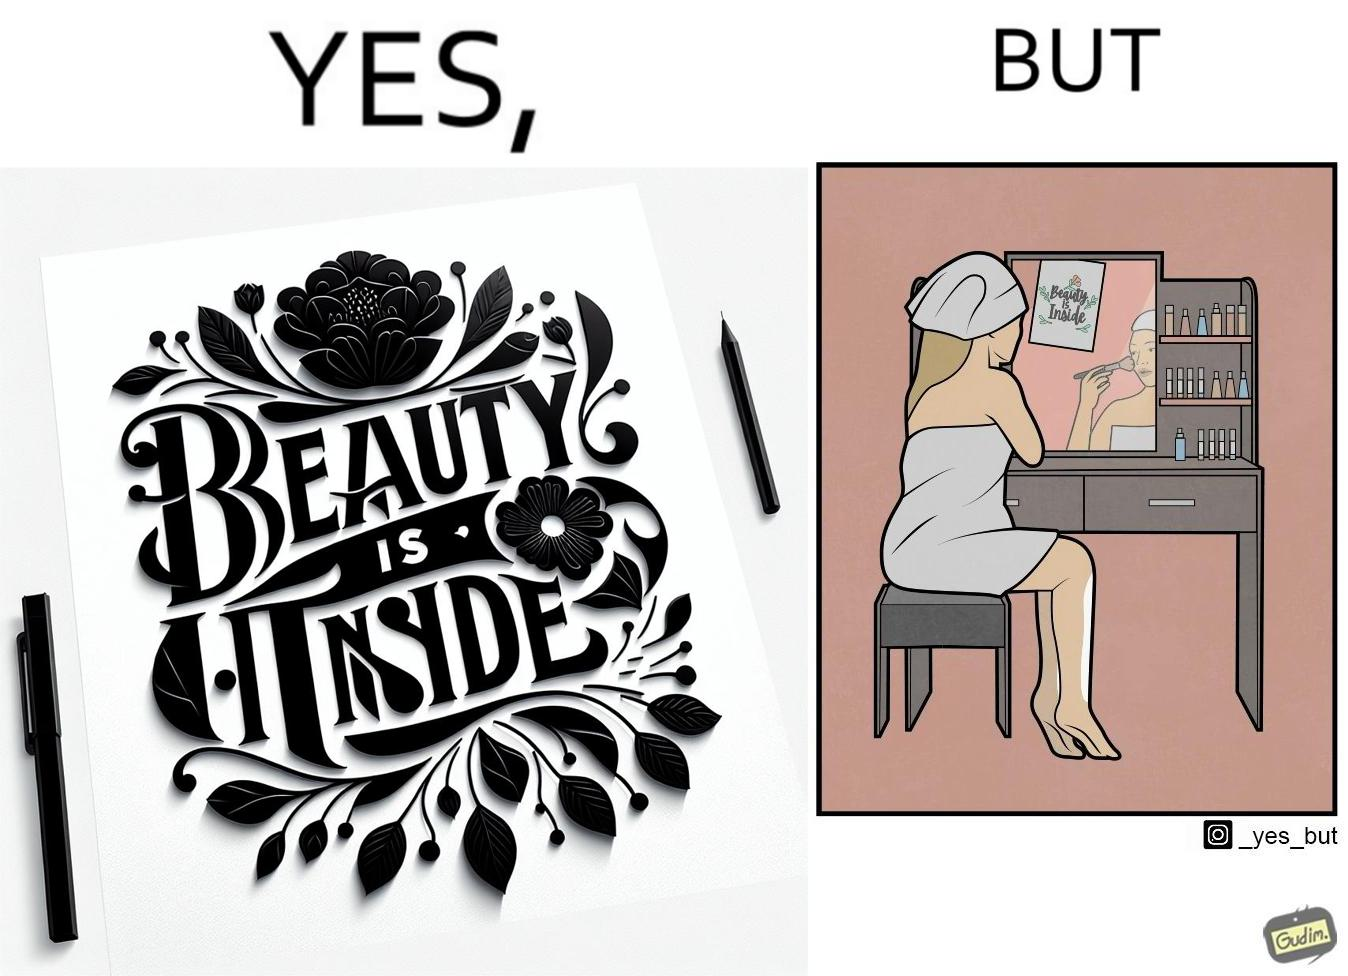Describe what you see in this image. The image is satirical because while the text on the paper says that beauty lies inside, the woman ignores the note and continues to apply makeup to improve her outer beauty. 